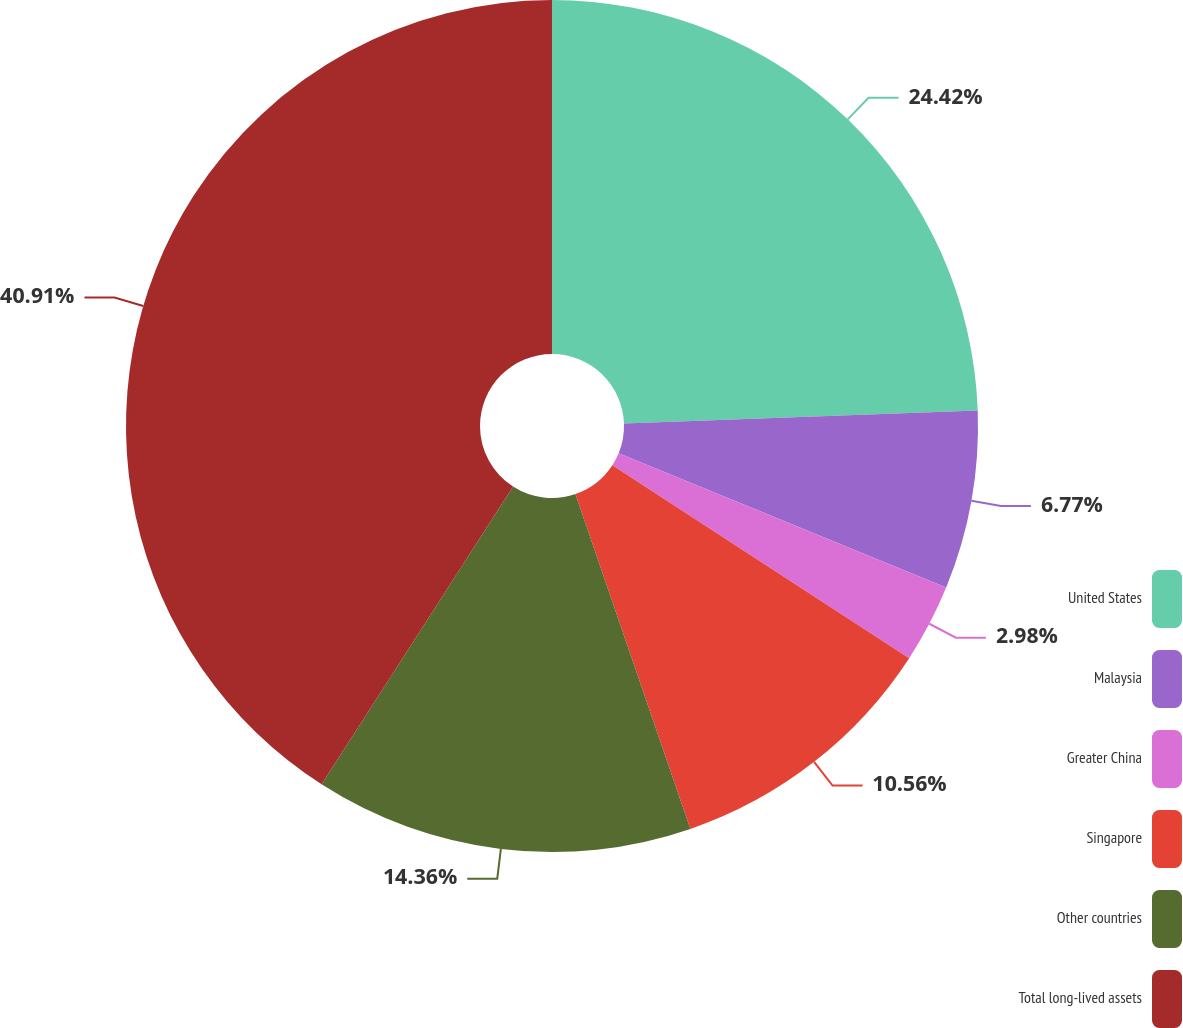<chart> <loc_0><loc_0><loc_500><loc_500><pie_chart><fcel>United States<fcel>Malaysia<fcel>Greater China<fcel>Singapore<fcel>Other countries<fcel>Total long-lived assets<nl><fcel>24.42%<fcel>6.77%<fcel>2.98%<fcel>10.56%<fcel>14.36%<fcel>40.9%<nl></chart> 